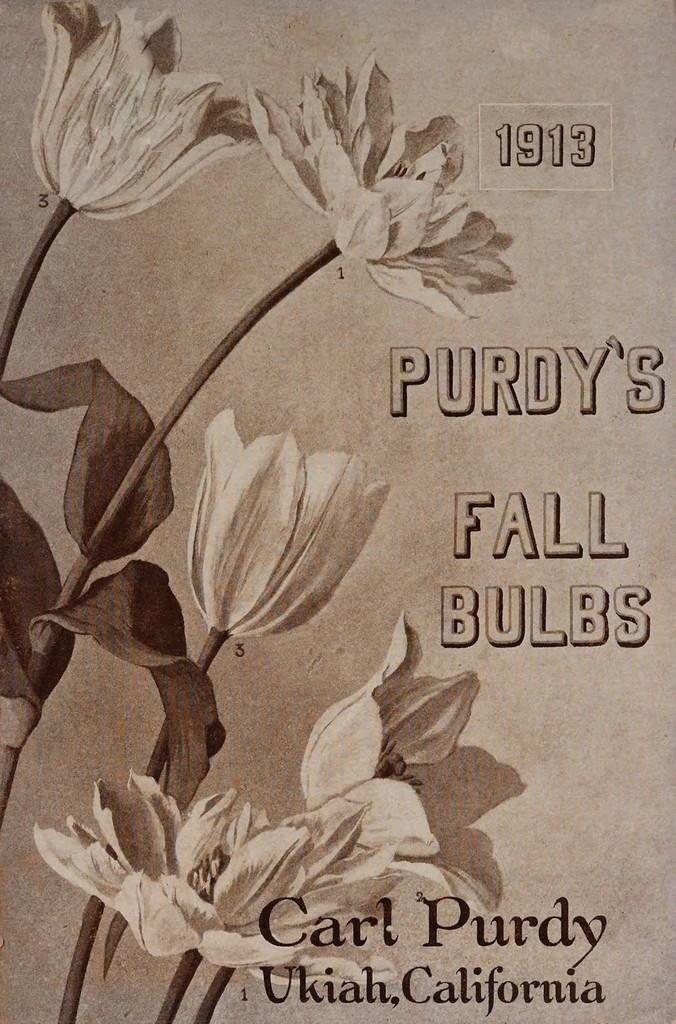What is the main object in the image? There is a card in the image. What design can be seen on the card? The card has flowers on it. Are there any words or phrases on the card? Yes, there is text on the card. How does the flame on the card affect the blood in the image? There is no flame or blood present in the image; it only features a card with flowers and text. 